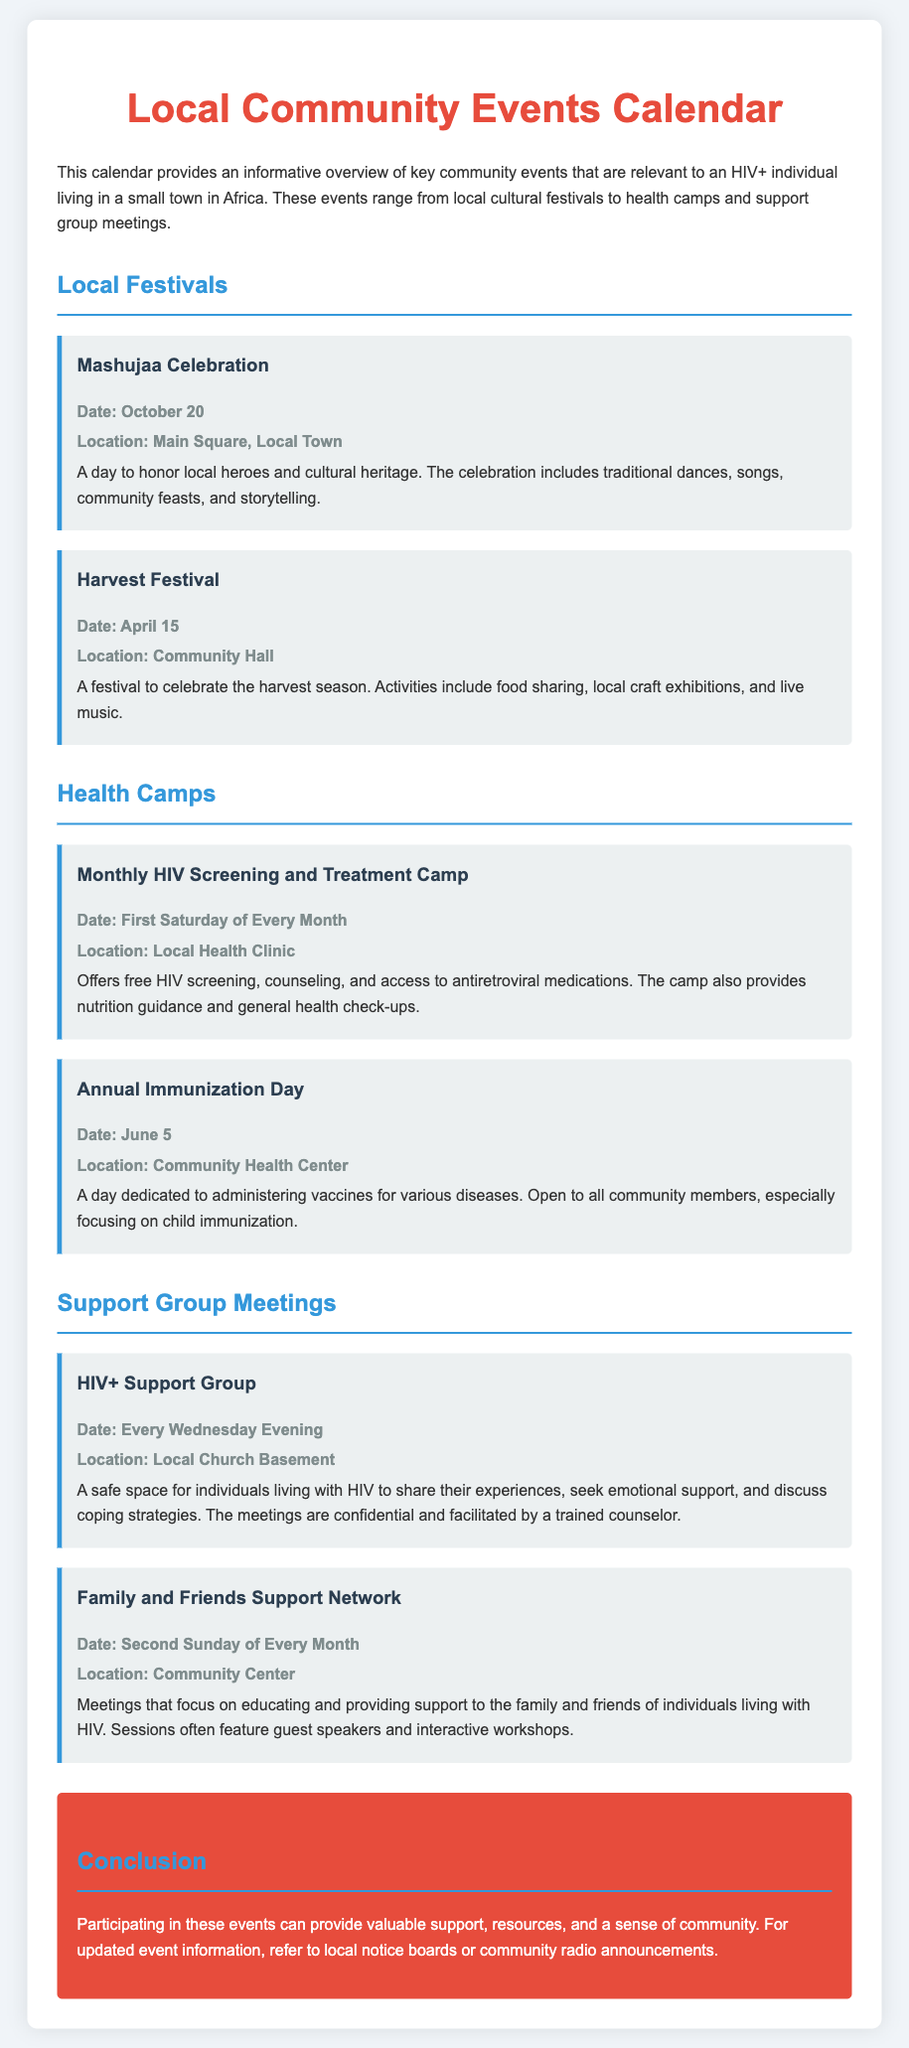What is the date of the Mashujaa Celebration? The date of the Mashujaa Celebration is listed in the document under Local Festivals.
Answer: October 20 Where is the Monthly HIV Screening and Treatment Camp held? The document indicates the location for the Monthly HIV Screening and Treatment Camp under Health Camps.
Answer: Local Health Clinic How often does the HIV+ Support Group meet? The document specifies the frequency of the HIV+ Support Group meetings under Support Group Meetings.
Answer: Every Wednesday Evening What type of event is the Harvest Festival? The type of event for the Harvest Festival is mentioned in the description under Local Festivals.
Answer: Food sharing, local craft exhibitions, and live music What is the focus of the Family and Friends Support Network meetings? The focus of the Family and Friends Support Network is outlined in the description under Support Group Meetings.
Answer: Educating and providing support to the family and friends of individuals living with HIV When does the Annual Immunization Day take place? The date for the Annual Immunization Day is specified under Health Camps.
Answer: June 5 What is the cultural significance of the Mashujaa Celebration? The document explains the cultural significance of the Mashujaa Celebration in the overview under Local Festivals.
Answer: To honor local heroes and cultural heritage What type of guidance is offered at the Monthly HIV Screening and Treatment Camp? The document lists the types of guidance provided at the Monthly HIV Screening and Treatment Camp under Health Camps.
Answer: Nutrition guidance What is the concluding message about the community events? The conclusion summarizes the purpose of participating in the events as stated in the conclusion section.
Answer: Provide valuable support, resources, and a sense of community 